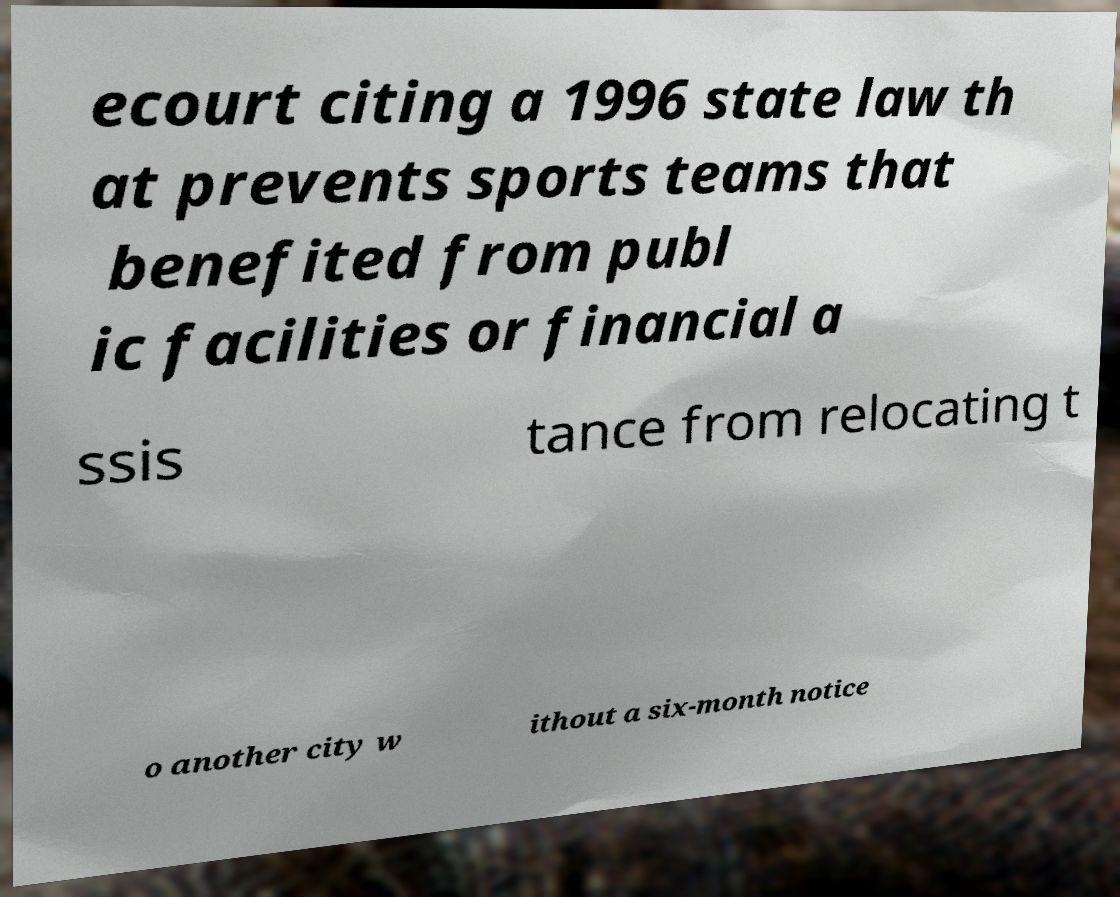Can you accurately transcribe the text from the provided image for me? ecourt citing a 1996 state law th at prevents sports teams that benefited from publ ic facilities or financial a ssis tance from relocating t o another city w ithout a six-month notice 